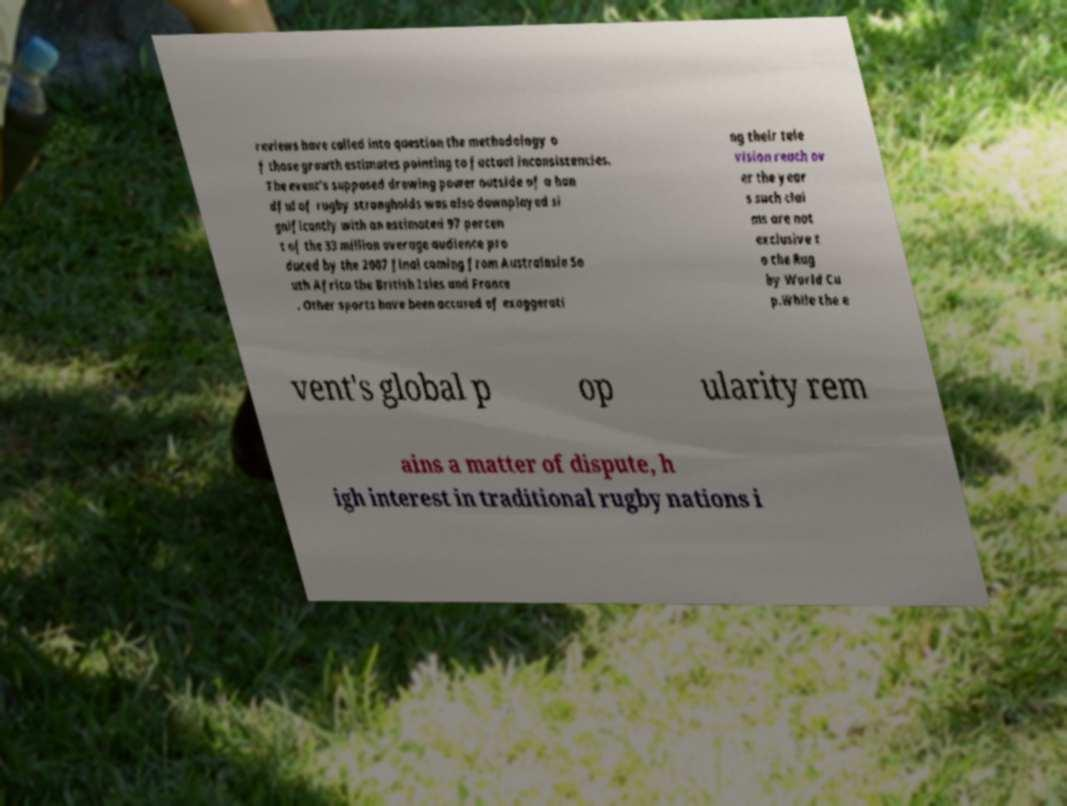Can you read and provide the text displayed in the image?This photo seems to have some interesting text. Can you extract and type it out for me? reviews have called into question the methodology o f those growth estimates pointing to factual inconsistencies. The event's supposed drawing power outside of a han dful of rugby strongholds was also downplayed si gnificantly with an estimated 97 percen t of the 33 million average audience pro duced by the 2007 final coming from Australasia So uth Africa the British Isles and France . Other sports have been accused of exaggerati ng their tele vision reach ov er the year s such clai ms are not exclusive t o the Rug by World Cu p.While the e vent's global p op ularity rem ains a matter of dispute, h igh interest in traditional rugby nations i 